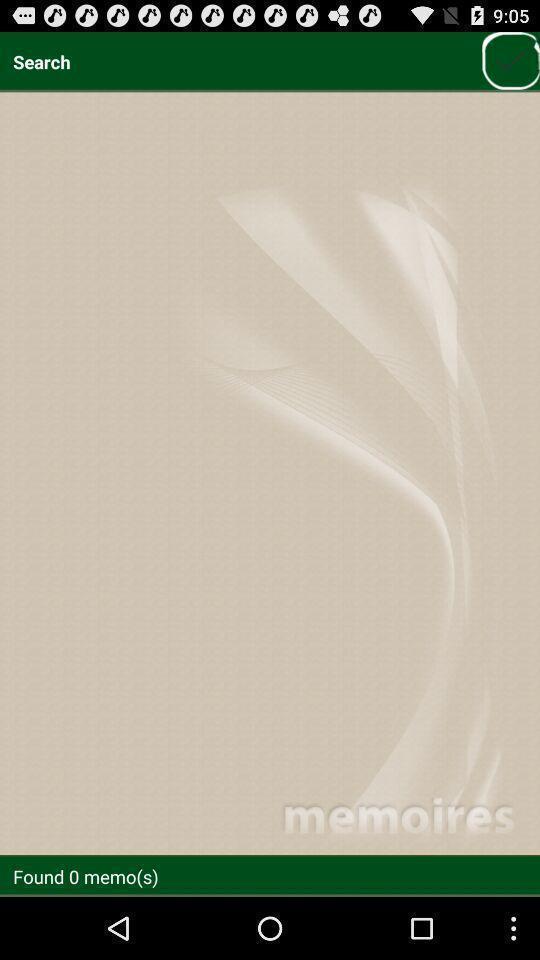What details can you identify in this image? Search page of find memories. 